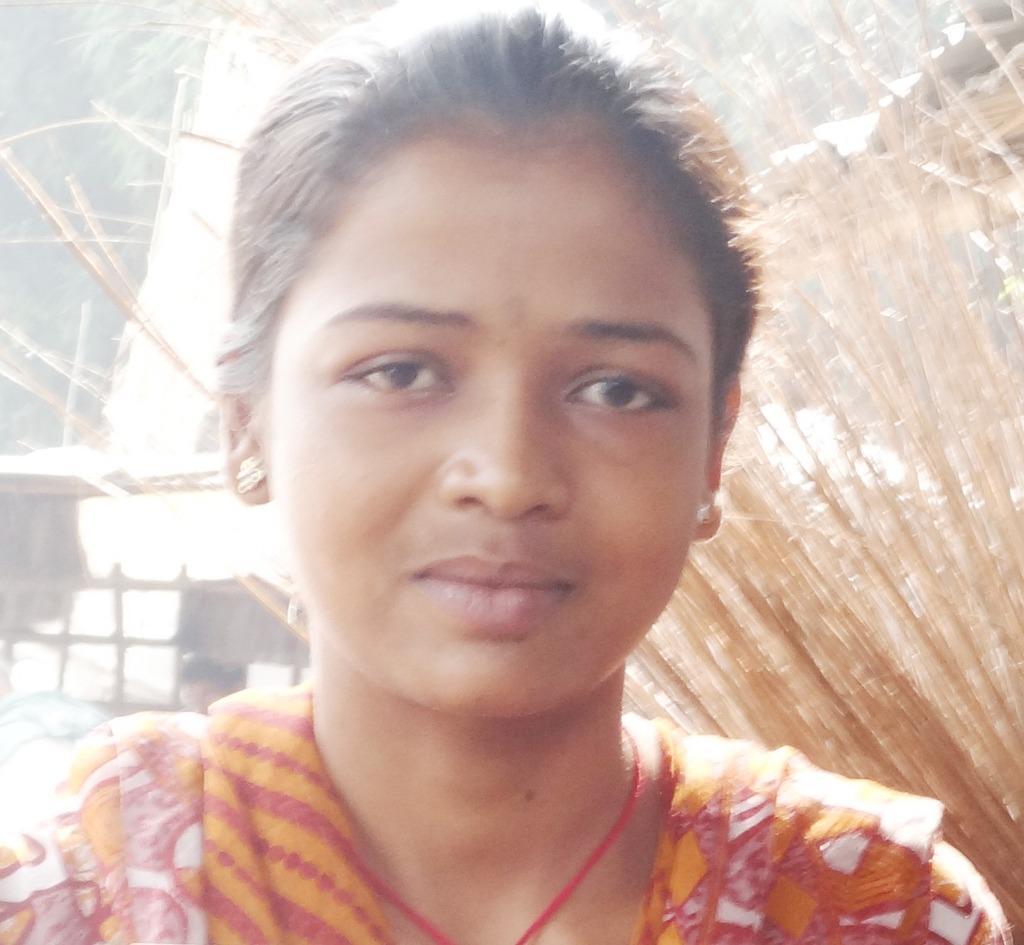Please provide a concise description of this image. In this image in the foreground there is one girl who is standing, in the background there are some wooden boards and wooden sticks and trees. 